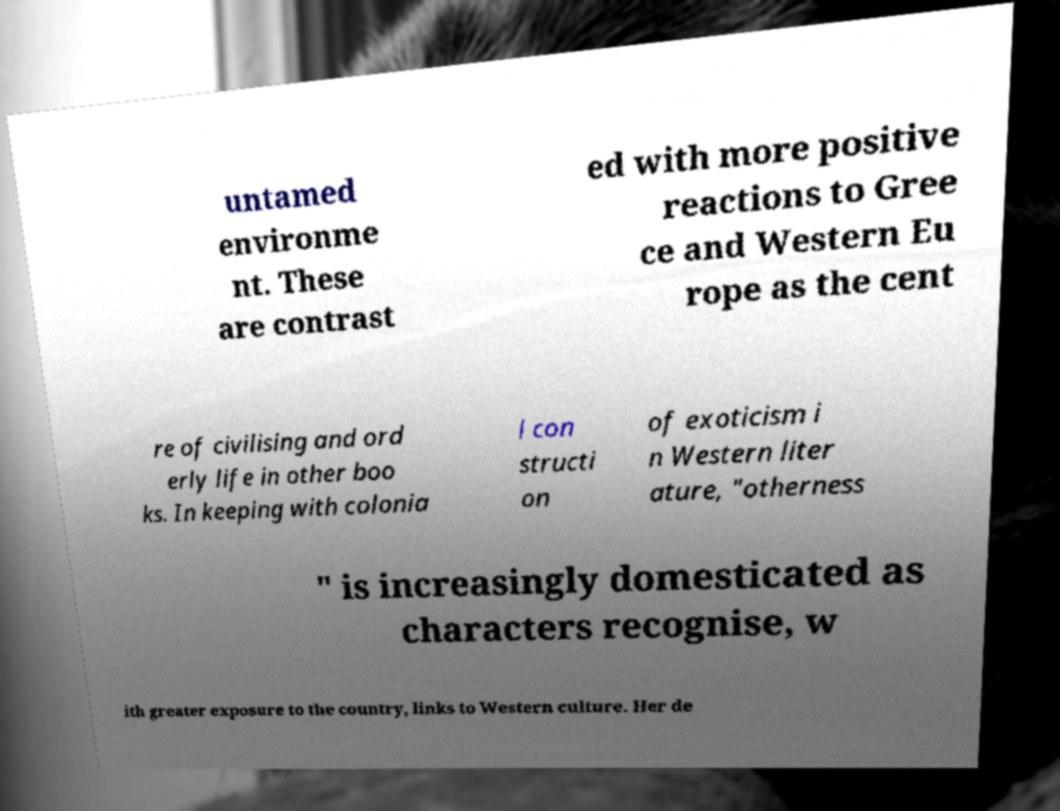Could you extract and type out the text from this image? untamed environme nt. These are contrast ed with more positive reactions to Gree ce and Western Eu rope as the cent re of civilising and ord erly life in other boo ks. In keeping with colonia l con structi on of exoticism i n Western liter ature, "otherness " is increasingly domesticated as characters recognise, w ith greater exposure to the country, links to Western culture. Her de 